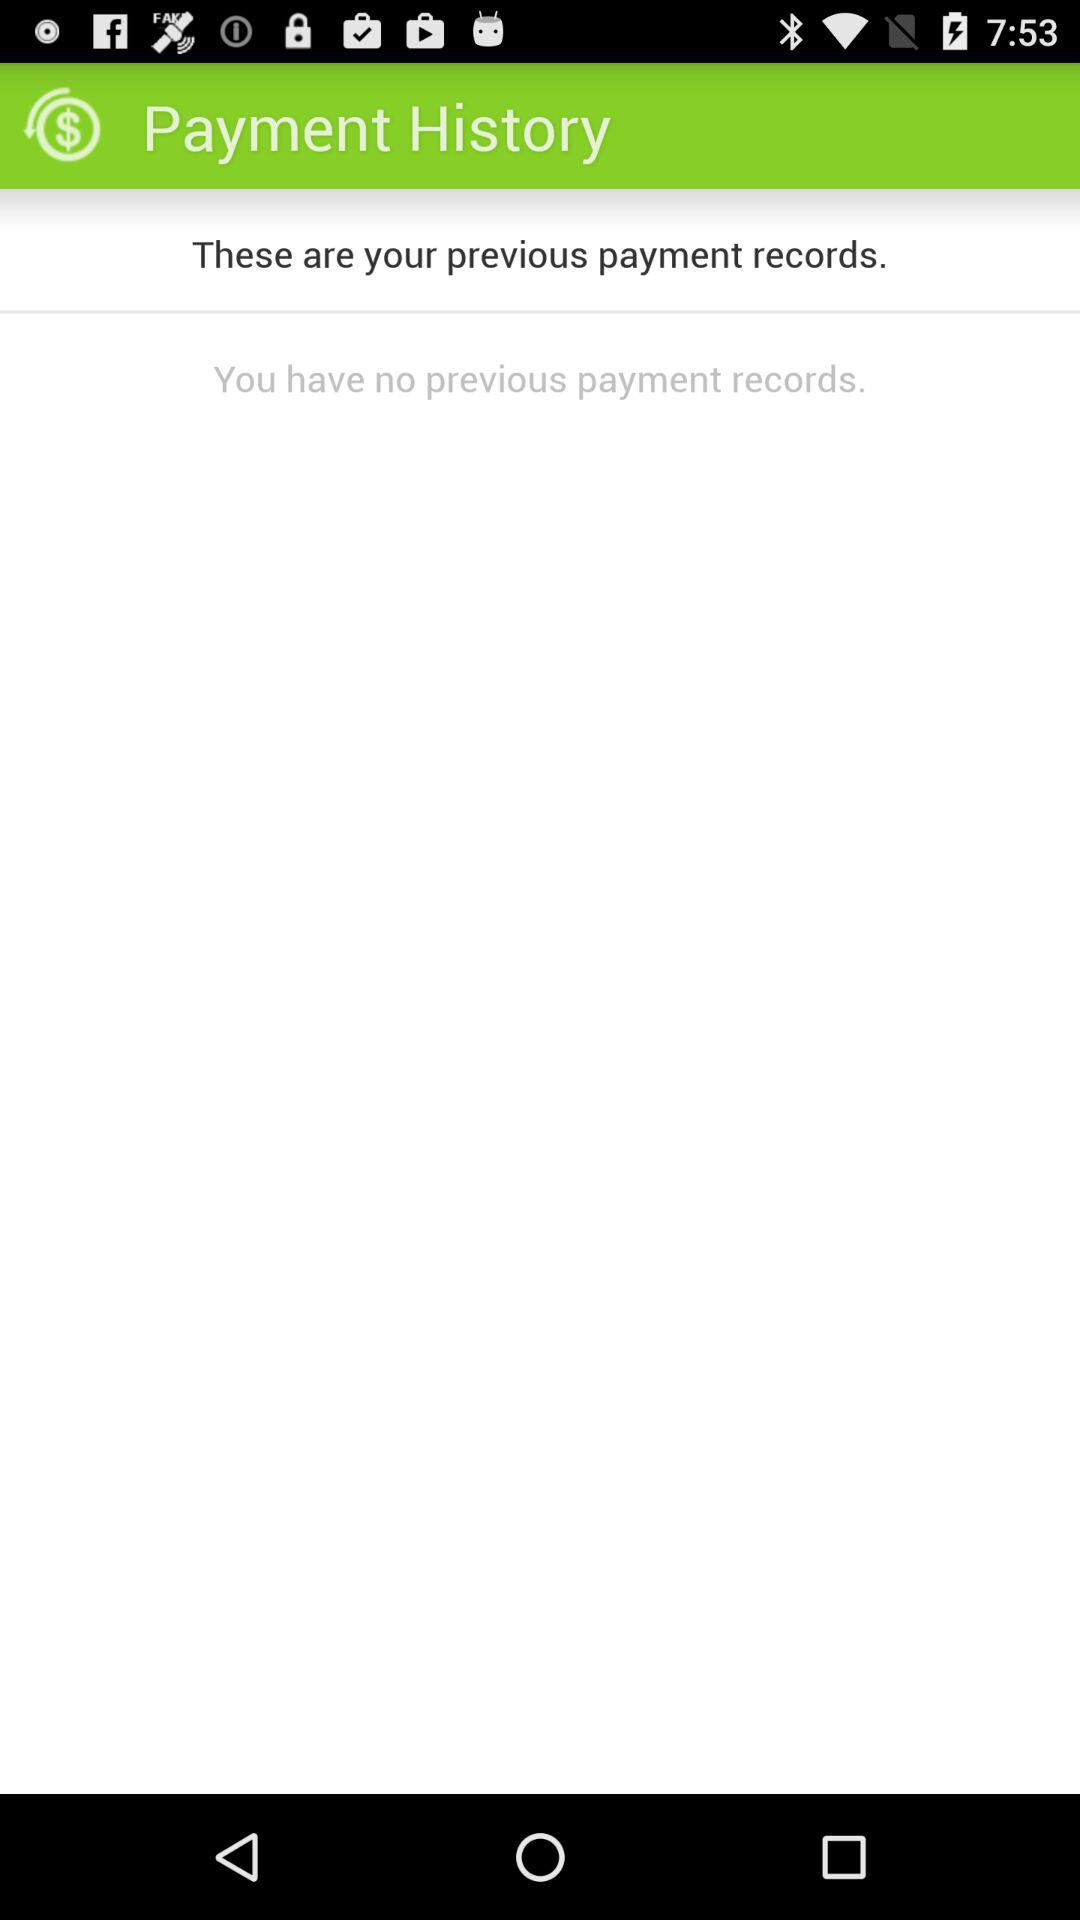How many payment records does the user have?
Answer the question using a single word or phrase. 0 